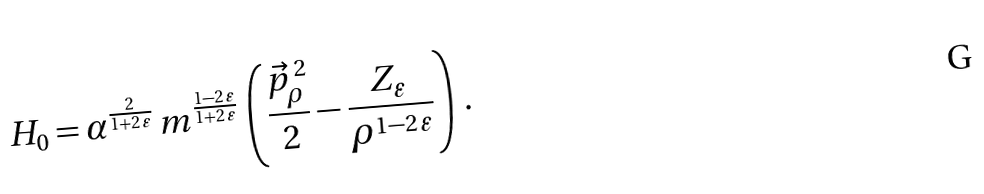<formula> <loc_0><loc_0><loc_500><loc_500>H _ { 0 } = \alpha ^ { \frac { 2 } { 1 + 2 \, \varepsilon } } \, m ^ { \frac { 1 - 2 \, \varepsilon } { 1 + 2 \, \varepsilon } } \, \left ( \frac { \vec { p } _ { \rho } ^ { \, 2 } } { 2 } - \frac { Z _ { \varepsilon } } { \rho ^ { 1 - 2 \, \varepsilon } } \right ) \, .</formula> 